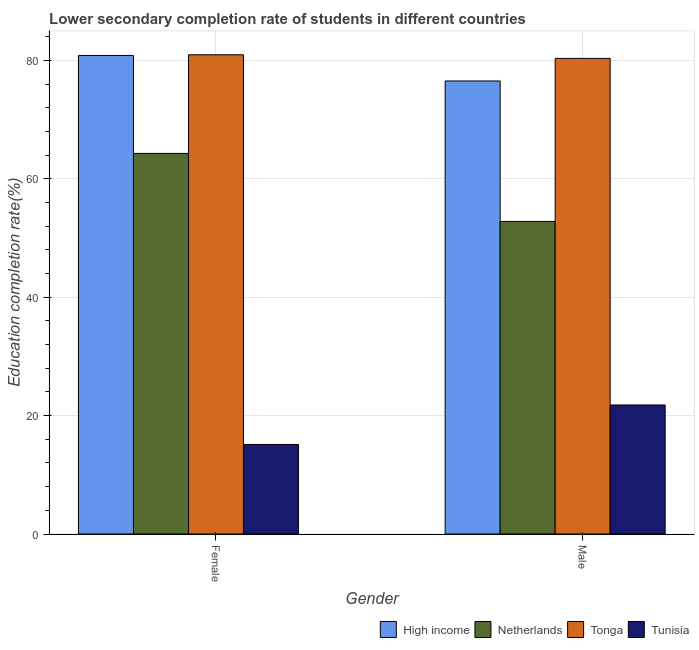How many different coloured bars are there?
Ensure brevity in your answer.  4. Are the number of bars per tick equal to the number of legend labels?
Offer a terse response. Yes. What is the label of the 1st group of bars from the left?
Offer a terse response. Female. What is the education completion rate of male students in High income?
Give a very brief answer. 76.53. Across all countries, what is the maximum education completion rate of male students?
Provide a short and direct response. 80.35. Across all countries, what is the minimum education completion rate of female students?
Make the answer very short. 15.13. In which country was the education completion rate of female students maximum?
Make the answer very short. Tonga. In which country was the education completion rate of male students minimum?
Provide a short and direct response. Tunisia. What is the total education completion rate of female students in the graph?
Provide a short and direct response. 241.22. What is the difference between the education completion rate of female students in Tunisia and that in Tonga?
Your answer should be compact. -65.83. What is the difference between the education completion rate of male students in Tonga and the education completion rate of female students in High income?
Keep it short and to the point. -0.5. What is the average education completion rate of female students per country?
Your answer should be very brief. 60.31. What is the difference between the education completion rate of female students and education completion rate of male students in High income?
Offer a terse response. 4.31. What is the ratio of the education completion rate of male students in High income to that in Tunisia?
Provide a succinct answer. 3.51. Is the education completion rate of female students in Tonga less than that in Tunisia?
Provide a succinct answer. No. In how many countries, is the education completion rate of female students greater than the average education completion rate of female students taken over all countries?
Ensure brevity in your answer.  3. What does the 1st bar from the left in Male represents?
Your answer should be compact. High income. How many bars are there?
Your answer should be compact. 8. Are all the bars in the graph horizontal?
Provide a short and direct response. No. Are the values on the major ticks of Y-axis written in scientific E-notation?
Keep it short and to the point. No. Does the graph contain any zero values?
Make the answer very short. No. Does the graph contain grids?
Your response must be concise. Yes. What is the title of the graph?
Make the answer very short. Lower secondary completion rate of students in different countries. What is the label or title of the X-axis?
Your answer should be very brief. Gender. What is the label or title of the Y-axis?
Offer a very short reply. Education completion rate(%). What is the Education completion rate(%) of High income in Female?
Provide a short and direct response. 80.84. What is the Education completion rate(%) in Netherlands in Female?
Your answer should be very brief. 64.3. What is the Education completion rate(%) in Tonga in Female?
Ensure brevity in your answer.  80.96. What is the Education completion rate(%) in Tunisia in Female?
Give a very brief answer. 15.13. What is the Education completion rate(%) in High income in Male?
Ensure brevity in your answer.  76.53. What is the Education completion rate(%) in Netherlands in Male?
Provide a succinct answer. 52.81. What is the Education completion rate(%) of Tonga in Male?
Your response must be concise. 80.35. What is the Education completion rate(%) of Tunisia in Male?
Give a very brief answer. 21.8. Across all Gender, what is the maximum Education completion rate(%) in High income?
Keep it short and to the point. 80.84. Across all Gender, what is the maximum Education completion rate(%) in Netherlands?
Give a very brief answer. 64.3. Across all Gender, what is the maximum Education completion rate(%) in Tonga?
Your answer should be very brief. 80.96. Across all Gender, what is the maximum Education completion rate(%) of Tunisia?
Your response must be concise. 21.8. Across all Gender, what is the minimum Education completion rate(%) in High income?
Give a very brief answer. 76.53. Across all Gender, what is the minimum Education completion rate(%) in Netherlands?
Keep it short and to the point. 52.81. Across all Gender, what is the minimum Education completion rate(%) of Tonga?
Provide a short and direct response. 80.35. Across all Gender, what is the minimum Education completion rate(%) of Tunisia?
Your answer should be compact. 15.13. What is the total Education completion rate(%) in High income in the graph?
Ensure brevity in your answer.  157.38. What is the total Education completion rate(%) in Netherlands in the graph?
Provide a short and direct response. 117.1. What is the total Education completion rate(%) in Tonga in the graph?
Offer a terse response. 161.3. What is the total Education completion rate(%) in Tunisia in the graph?
Make the answer very short. 36.93. What is the difference between the Education completion rate(%) in High income in Female and that in Male?
Make the answer very short. 4.31. What is the difference between the Education completion rate(%) in Netherlands in Female and that in Male?
Ensure brevity in your answer.  11.49. What is the difference between the Education completion rate(%) in Tonga in Female and that in Male?
Ensure brevity in your answer.  0.61. What is the difference between the Education completion rate(%) in Tunisia in Female and that in Male?
Ensure brevity in your answer.  -6.67. What is the difference between the Education completion rate(%) of High income in Female and the Education completion rate(%) of Netherlands in Male?
Give a very brief answer. 28.04. What is the difference between the Education completion rate(%) of High income in Female and the Education completion rate(%) of Tonga in Male?
Your answer should be compact. 0.5. What is the difference between the Education completion rate(%) of High income in Female and the Education completion rate(%) of Tunisia in Male?
Your answer should be compact. 59.05. What is the difference between the Education completion rate(%) of Netherlands in Female and the Education completion rate(%) of Tonga in Male?
Offer a very short reply. -16.05. What is the difference between the Education completion rate(%) of Netherlands in Female and the Education completion rate(%) of Tunisia in Male?
Ensure brevity in your answer.  42.5. What is the difference between the Education completion rate(%) of Tonga in Female and the Education completion rate(%) of Tunisia in Male?
Provide a succinct answer. 59.16. What is the average Education completion rate(%) of High income per Gender?
Your answer should be compact. 78.69. What is the average Education completion rate(%) in Netherlands per Gender?
Provide a short and direct response. 58.55. What is the average Education completion rate(%) of Tonga per Gender?
Offer a very short reply. 80.65. What is the average Education completion rate(%) of Tunisia per Gender?
Your answer should be compact. 18.46. What is the difference between the Education completion rate(%) in High income and Education completion rate(%) in Netherlands in Female?
Your response must be concise. 16.55. What is the difference between the Education completion rate(%) of High income and Education completion rate(%) of Tonga in Female?
Offer a terse response. -0.11. What is the difference between the Education completion rate(%) in High income and Education completion rate(%) in Tunisia in Female?
Offer a very short reply. 65.72. What is the difference between the Education completion rate(%) in Netherlands and Education completion rate(%) in Tonga in Female?
Give a very brief answer. -16.66. What is the difference between the Education completion rate(%) of Netherlands and Education completion rate(%) of Tunisia in Female?
Provide a succinct answer. 49.17. What is the difference between the Education completion rate(%) in Tonga and Education completion rate(%) in Tunisia in Female?
Your answer should be compact. 65.83. What is the difference between the Education completion rate(%) of High income and Education completion rate(%) of Netherlands in Male?
Provide a short and direct response. 23.72. What is the difference between the Education completion rate(%) of High income and Education completion rate(%) of Tonga in Male?
Your answer should be compact. -3.81. What is the difference between the Education completion rate(%) of High income and Education completion rate(%) of Tunisia in Male?
Provide a succinct answer. 54.73. What is the difference between the Education completion rate(%) in Netherlands and Education completion rate(%) in Tonga in Male?
Your response must be concise. -27.54. What is the difference between the Education completion rate(%) in Netherlands and Education completion rate(%) in Tunisia in Male?
Give a very brief answer. 31.01. What is the difference between the Education completion rate(%) of Tonga and Education completion rate(%) of Tunisia in Male?
Ensure brevity in your answer.  58.55. What is the ratio of the Education completion rate(%) in High income in Female to that in Male?
Offer a terse response. 1.06. What is the ratio of the Education completion rate(%) of Netherlands in Female to that in Male?
Offer a terse response. 1.22. What is the ratio of the Education completion rate(%) in Tonga in Female to that in Male?
Keep it short and to the point. 1.01. What is the ratio of the Education completion rate(%) of Tunisia in Female to that in Male?
Ensure brevity in your answer.  0.69. What is the difference between the highest and the second highest Education completion rate(%) in High income?
Your answer should be very brief. 4.31. What is the difference between the highest and the second highest Education completion rate(%) of Netherlands?
Provide a succinct answer. 11.49. What is the difference between the highest and the second highest Education completion rate(%) of Tonga?
Your response must be concise. 0.61. What is the difference between the highest and the second highest Education completion rate(%) of Tunisia?
Your answer should be very brief. 6.67. What is the difference between the highest and the lowest Education completion rate(%) of High income?
Ensure brevity in your answer.  4.31. What is the difference between the highest and the lowest Education completion rate(%) in Netherlands?
Your answer should be very brief. 11.49. What is the difference between the highest and the lowest Education completion rate(%) of Tonga?
Keep it short and to the point. 0.61. What is the difference between the highest and the lowest Education completion rate(%) in Tunisia?
Give a very brief answer. 6.67. 